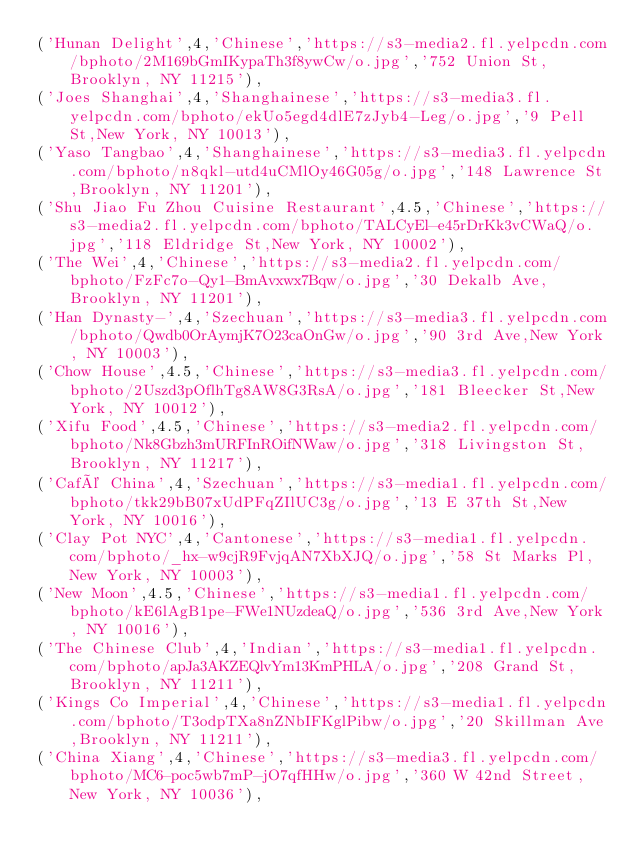<code> <loc_0><loc_0><loc_500><loc_500><_SQL_>('Hunan Delight',4,'Chinese','https://s3-media2.fl.yelpcdn.com/bphoto/2M169bGmIKypaTh3f8ywCw/o.jpg','752 Union St,Brooklyn, NY 11215'),
('Joes Shanghai',4,'Shanghainese','https://s3-media3.fl.yelpcdn.com/bphoto/ekUo5egd4dlE7zJyb4-Leg/o.jpg','9 Pell St,New York, NY 10013'),
('Yaso Tangbao',4,'Shanghainese','https://s3-media3.fl.yelpcdn.com/bphoto/n8qkl-utd4uCMlOy46G05g/o.jpg','148 Lawrence St,Brooklyn, NY 11201'),
('Shu Jiao Fu Zhou Cuisine Restaurant',4.5,'Chinese','https://s3-media2.fl.yelpcdn.com/bphoto/TALCyEl-e45rDrKk3vCWaQ/o.jpg','118 Eldridge St,New York, NY 10002'),
('The Wei',4,'Chinese','https://s3-media2.fl.yelpcdn.com/bphoto/FzFc7o-Qy1-BmAvxwx7Bqw/o.jpg','30 Dekalb Ave,Brooklyn, NY 11201'),
('Han Dynasty-',4,'Szechuan','https://s3-media3.fl.yelpcdn.com/bphoto/Qwdb0OrAymjK7O23caOnGw/o.jpg','90 3rd Ave,New York, NY 10003'),
('Chow House',4.5,'Chinese','https://s3-media3.fl.yelpcdn.com/bphoto/2Uszd3pOflhTg8AW8G3RsA/o.jpg','181 Bleecker St,New York, NY 10012'),
('Xifu Food',4.5,'Chinese','https://s3-media2.fl.yelpcdn.com/bphoto/Nk8Gbzh3mURFInROifNWaw/o.jpg','318 Livingston St,Brooklyn, NY 11217'),
('Café China',4,'Szechuan','https://s3-media1.fl.yelpcdn.com/bphoto/tkk29bB07xUdPFqZIlUC3g/o.jpg','13 E 37th St,New York, NY 10016'),
('Clay Pot NYC',4,'Cantonese','https://s3-media1.fl.yelpcdn.com/bphoto/_hx-w9cjR9FvjqAN7XbXJQ/o.jpg','58 St Marks Pl,New York, NY 10003'),
('New Moon',4.5,'Chinese','https://s3-media1.fl.yelpcdn.com/bphoto/kE6lAgB1pe-FWe1NUzdeaQ/o.jpg','536 3rd Ave,New York, NY 10016'),
('The Chinese Club',4,'Indian','https://s3-media1.fl.yelpcdn.com/bphoto/apJa3AKZEQlvYm13KmPHLA/o.jpg','208 Grand St,Brooklyn, NY 11211'),
('Kings Co Imperial',4,'Chinese','https://s3-media1.fl.yelpcdn.com/bphoto/T3odpTXa8nZNbIFKglPibw/o.jpg','20 Skillman Ave,Brooklyn, NY 11211'),
('China Xiang',4,'Chinese','https://s3-media3.fl.yelpcdn.com/bphoto/MC6-poc5wb7mP-jO7qfHHw/o.jpg','360 W 42nd Street,New York, NY 10036'),</code> 